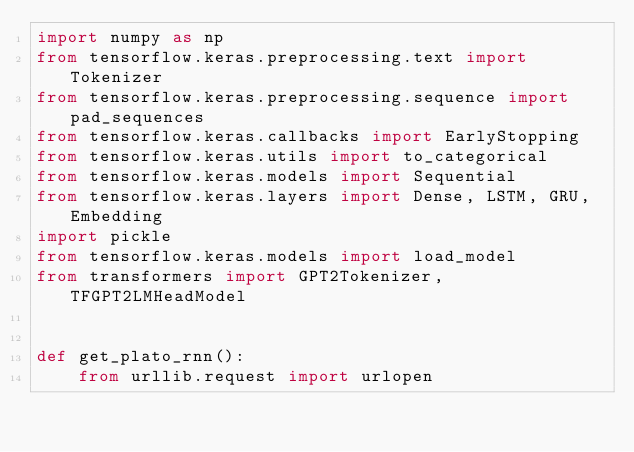<code> <loc_0><loc_0><loc_500><loc_500><_Python_>import numpy as np
from tensorflow.keras.preprocessing.text import Tokenizer
from tensorflow.keras.preprocessing.sequence import pad_sequences
from tensorflow.keras.callbacks import EarlyStopping
from tensorflow.keras.utils import to_categorical
from tensorflow.keras.models import Sequential
from tensorflow.keras.layers import Dense, LSTM, GRU, Embedding
import pickle
from tensorflow.keras.models import load_model
from transformers import GPT2Tokenizer, TFGPT2LMHeadModel


def get_plato_rnn():
    from urllib.request import urlopen</code> 